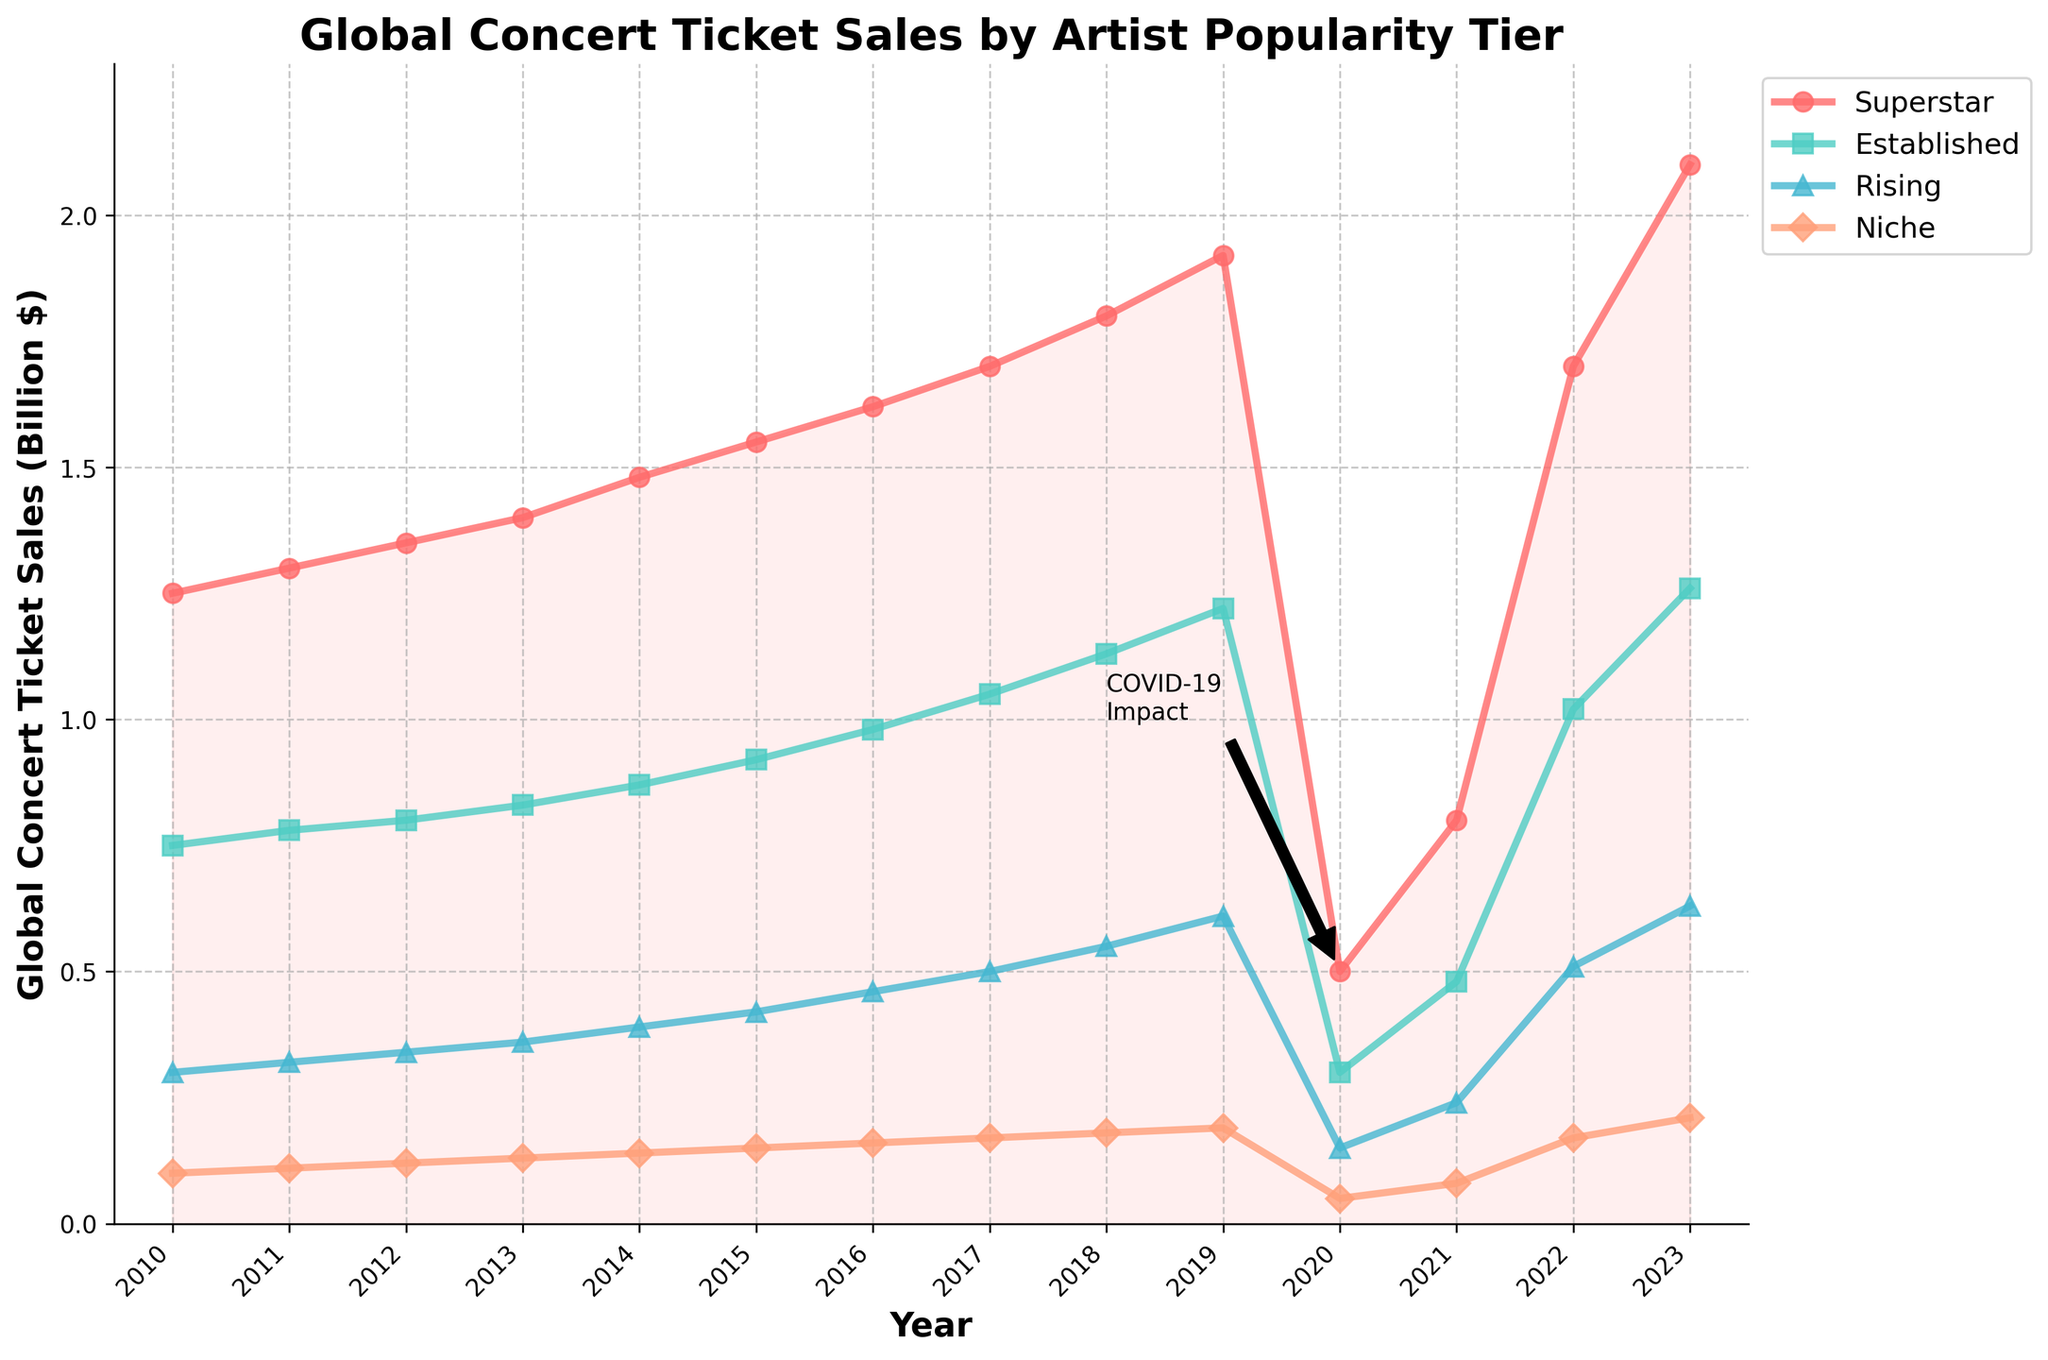How did concert ticket sales for Superstars change over the years from 2010 to 2023? From 2010 to 2019, sales increased steadily from $1.25 billion to $1.92 billion. There is a notable drop in 2020 to $0.5 billion due to COVID-19. Sales then recovered to reach $2.1 billion by 2023.
Answer: Steady increase, drop in 2020, then recovery What was the percentage drop in ticket sales for Rising artists from 2019 to 2020? Rising artists' sales dropped from $610 million in 2019 to $150 million in 2020. The percentage drop is ((610 - 150) / 610) * 100.
Answer: 75.41% Which artist popularity tier had the highest sales in 2023? By looking at the y-axis values for 2023, Superstars had the highest sales, above all other tiers.
Answer: Superstars Are established artists' ticket sales always higher than rising artists' ticket sales over the years? By comparing the sales lines for Established and Rising artists over the years, Established artists' sales are consistently higher each year.
Answer: Yes What is the difference in ticket sales between Superstars and Niche artists in 2017? In 2017, Superstars sold $1.7 billion, and Niche artists sold $170 million. The difference is $1.7 billion - $170 million.
Answer: $1.53 billion Which year shows the largest increase in ticket sales for Niche artists from the previous year? By examining the year-to-year change for Niche artists, the largest increase is from 2021 to 2022 (from $80 million to $170 million).
Answer: 2022 What is the combined ticket sales for all artist tiers in 2014? Add ticket sales of all tiers in 2014: $1.48 billion + $0.87 billion + $0.39 billion + $0.14 billion.
Answer: $2.88 billion In which year did Superstars have the smallest proportion of the total ticket sales among all artist tiers? Calculate the proportion of Superstars in total sales for each year. In 2020 (COVID-19 impact year), the proportion is smallest ($0.5 billion out of $1 billion total).
Answer: 2020 Did any artist tier surpass their 2019 ticket sales by 2023? By checking the sales values for each tier in 2019 and 2023, Superstars ($2.10 billion) and Established artists ($1.26 billion) surpassed their 2019 sales ($1.92 billion and $1.22 billion, respectively).
Answer: Yes Which year does the annotation "COVID-19 Impact" refer to? The annotation points with an arrow to the year 2020 and mentions the impact, indicating the significant drop in ticket sales for that year.
Answer: 2020 